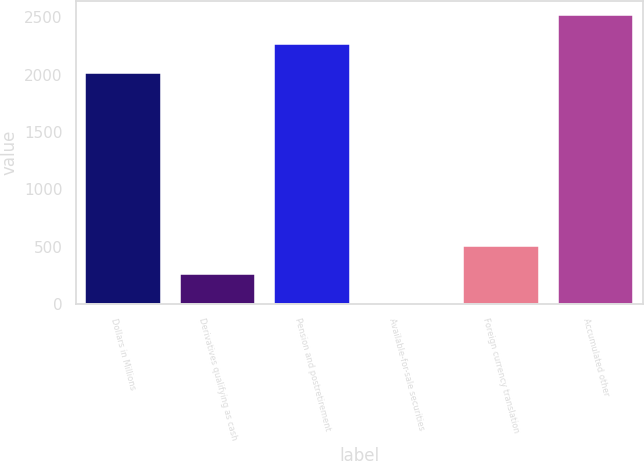Convert chart. <chart><loc_0><loc_0><loc_500><loc_500><bar_chart><fcel>Dollars in Millions<fcel>Derivatives qualifying as cash<fcel>Pension and postretirement<fcel>Available-for-sale securities<fcel>Foreign currency translation<fcel>Accumulated other<nl><fcel>2016<fcel>256.6<fcel>2265.6<fcel>7<fcel>506.2<fcel>2515.2<nl></chart> 